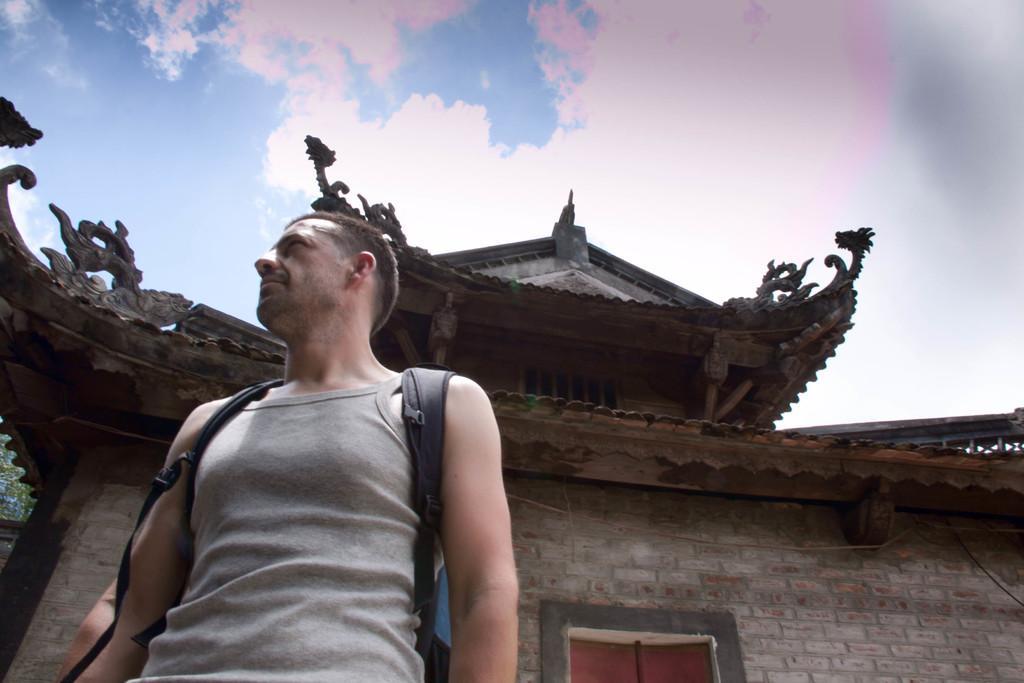In one or two sentences, can you explain what this image depicts? In this image we can see there is a person wearing a bag and looking to the left side of the image, behind the person there is a building. In the background there is a sky. 